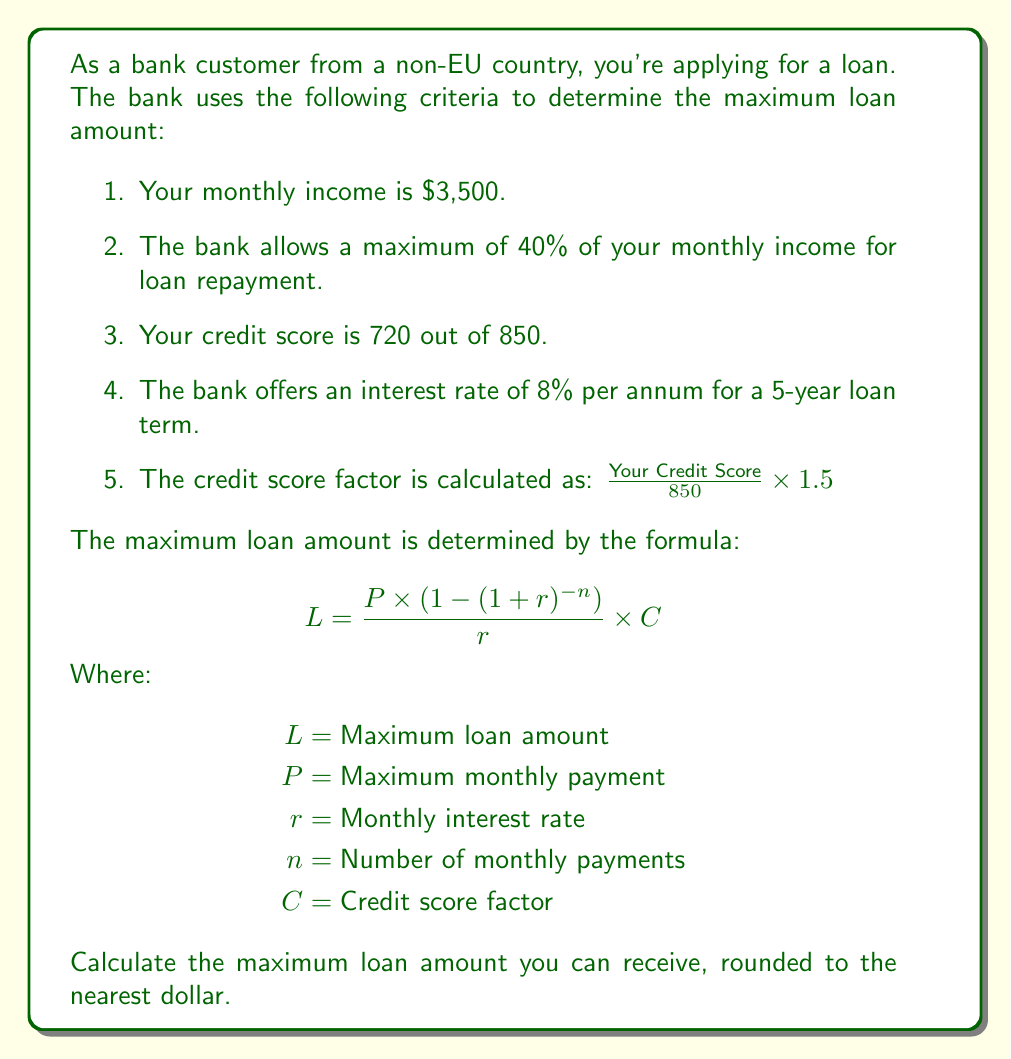Provide a solution to this math problem. Let's solve this problem step by step:

1. Calculate the maximum monthly payment ($P$):
   $P = 40\% \times \$3,500 = 0.4 \times \$3,500 = \$1,400$

2. Calculate the monthly interest rate ($r$):
   Annual rate = 8% = 0.08
   $r = 0.08 \div 12 = 0.00667$ (rounded to 5 decimal places)

3. Determine the number of monthly payments ($n$):
   5 years = 60 months, so $n = 60$

4. Calculate the credit score factor ($C$):
   $C = \frac{720}{850} \times 1.5 = 1.2706$ (rounded to 4 decimal places)

5. Now, let's use the formula to calculate the maximum loan amount:

   $$L = \frac{P \times (1 - (1 + r)^{-n})}{r} \times C$$

   Substituting the values:

   $$L = \frac{1400 \times (1 - (1 + 0.00667)^{-60})}{0.00667} \times 1.2706$$

6. Simplify:
   $$L = \frac{1400 \times 0.3292}{0.00667} \times 1.2706$$
   $$L = 69,070.91 \times 1.2706$$
   $$L = 87,759.49$$

7. Rounding to the nearest dollar:
   $L = \$87,759$
Answer: The maximum loan amount you can receive is $\$87,759$. 